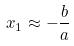<formula> <loc_0><loc_0><loc_500><loc_500>x _ { 1 } \approx - \frac { b } { a }</formula> 